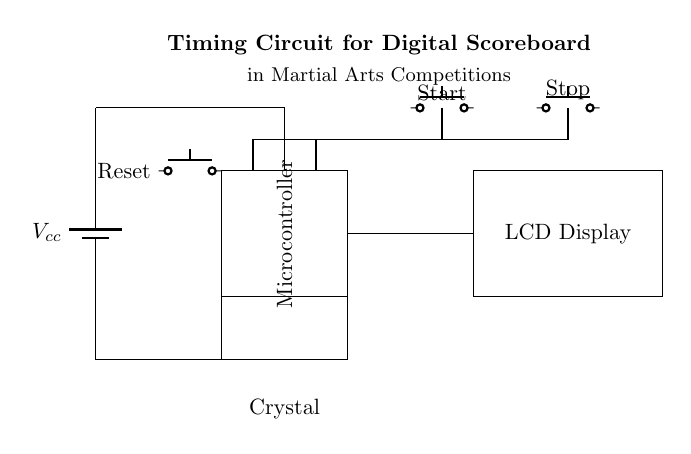What is the component that generates the timing signal? The component responsible for generating the timing signal in this circuit is the crystal oscillator, shown at the bottom left of the diagram. It produces a consistent frequency used to control the timing of the scoreboard.
Answer: Crystal oscillator What is the function of the push button labeled "Reset"? The "Reset" push button is used to restart the microcontroller and all associated circuitry, returning the scoreboard to its initial state. This action ensures that the scoreboard starts counting from zero or any predefined starting point when pressed.
Answer: Reset What is the intended display for this circuit? The intended display for this circuit is an LCD Display, which shows the scoring and timing for the martial arts competition. Its presence is crucial for visual representation of the scores during matches.
Answer: LCD Display How many push buttons are present in this circuit? There are three push buttons in this circuit: one labeled "Reset," one labeled "Start," and one labeled "Stop." Each plays a critical role in controlling the timer and scoreboard functionality.
Answer: Three Which component serves as the main control unit in the circuit? The main control unit in this circuit is the microcontroller, located centrally in the schematic. It processes inputs from the push buttons and controls the output to the LCD Display based on those actions.
Answer: Microcontroller What is the power supply voltage represented in the circuit? The power supply voltage represented in the circuit is denoted as Vcc, but the exact numerical value is not specified in the schematic. It is typically a standard voltage such as 5 volts.
Answer: Vcc 